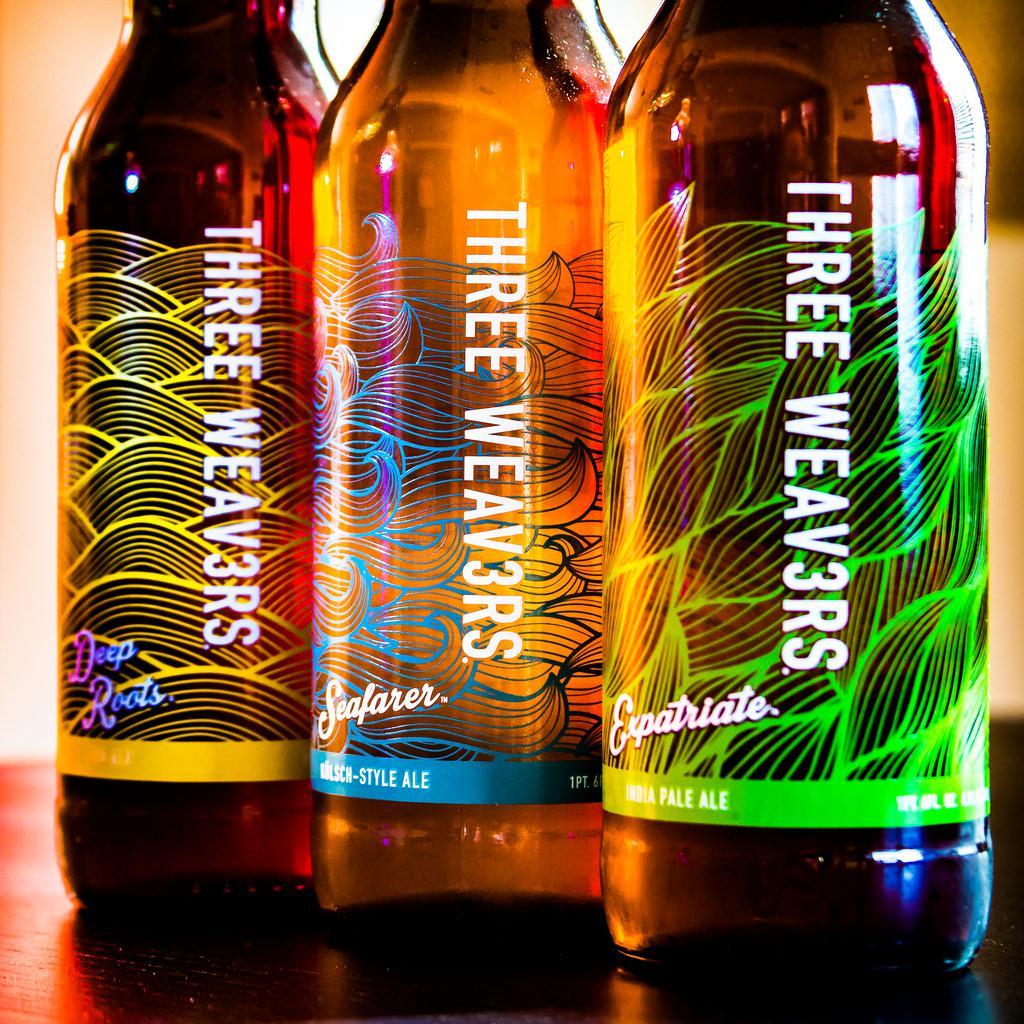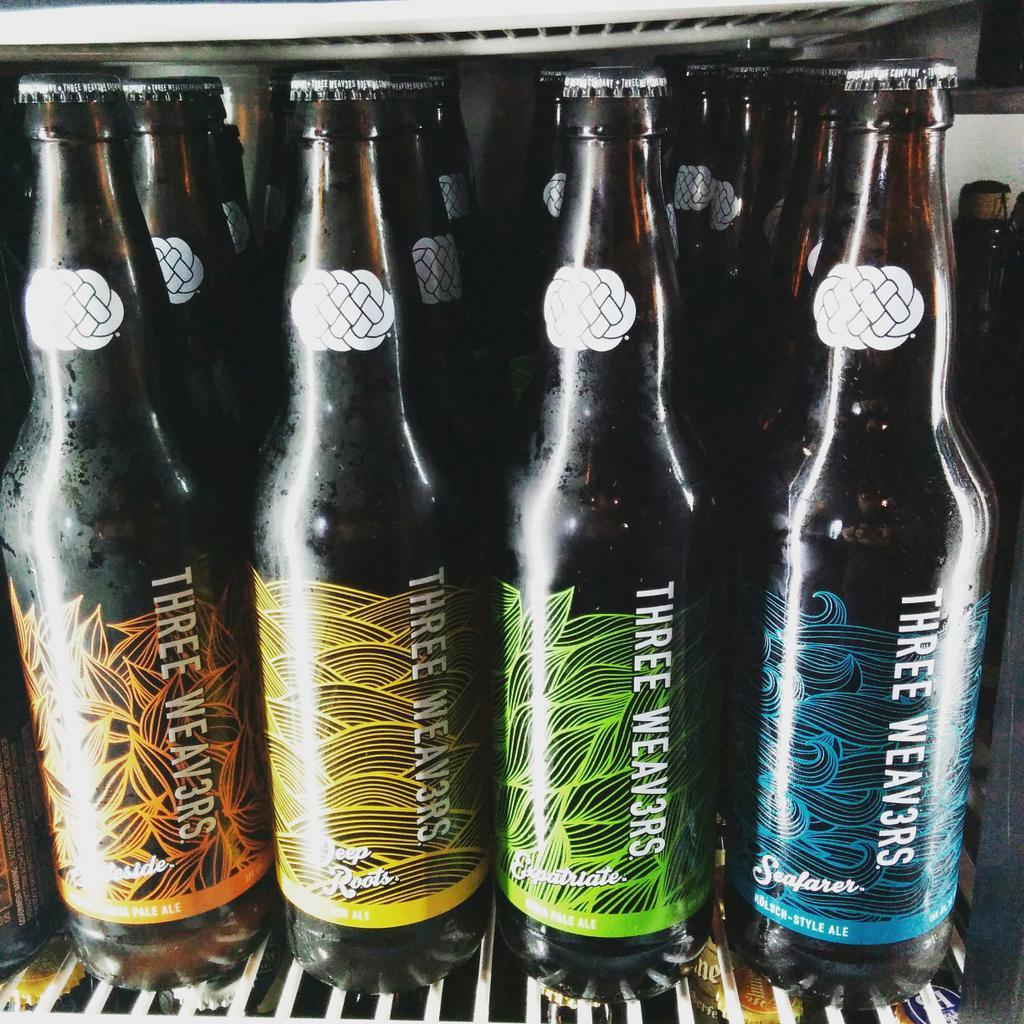The first image is the image on the left, the second image is the image on the right. Considering the images on both sides, is "In one image, bottles of ale fill the shelf of a cooler." valid? Answer yes or no. Yes. 